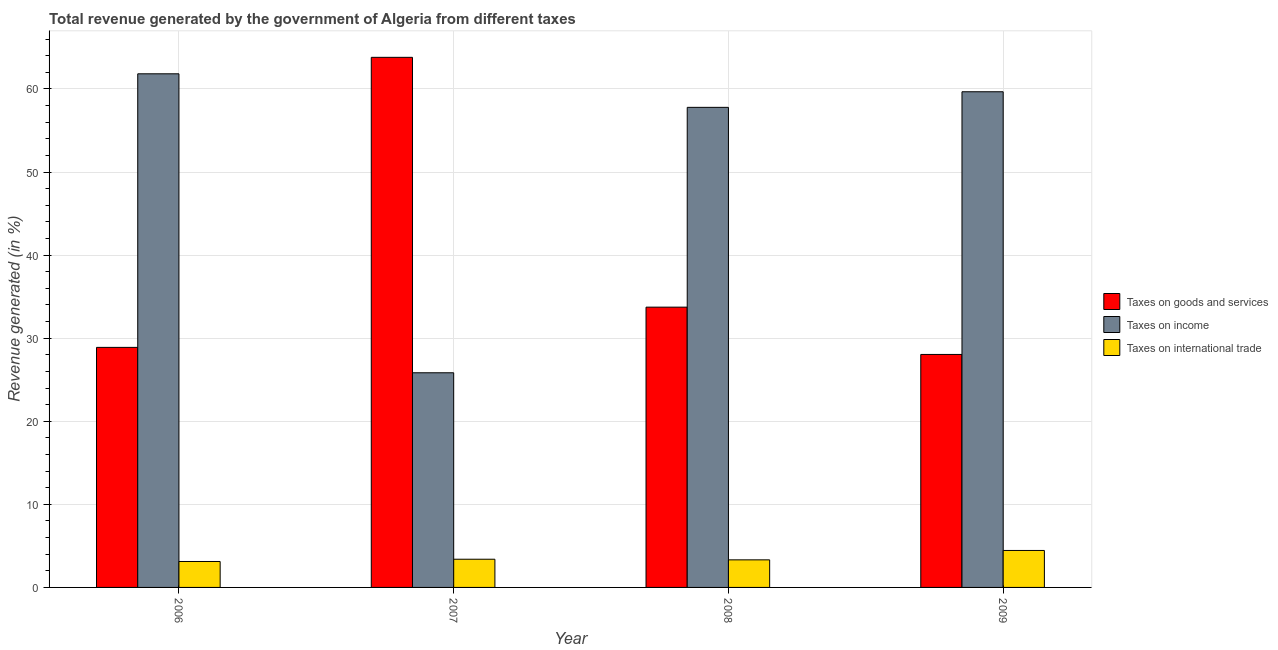How many different coloured bars are there?
Keep it short and to the point. 3. Are the number of bars per tick equal to the number of legend labels?
Your response must be concise. Yes. What is the label of the 1st group of bars from the left?
Provide a short and direct response. 2006. In how many cases, is the number of bars for a given year not equal to the number of legend labels?
Keep it short and to the point. 0. What is the percentage of revenue generated by taxes on goods and services in 2007?
Provide a succinct answer. 63.81. Across all years, what is the maximum percentage of revenue generated by taxes on goods and services?
Your answer should be very brief. 63.81. Across all years, what is the minimum percentage of revenue generated by tax on international trade?
Your response must be concise. 3.12. In which year was the percentage of revenue generated by taxes on income maximum?
Make the answer very short. 2006. What is the total percentage of revenue generated by taxes on income in the graph?
Make the answer very short. 205.11. What is the difference between the percentage of revenue generated by tax on international trade in 2008 and that in 2009?
Make the answer very short. -1.13. What is the difference between the percentage of revenue generated by taxes on goods and services in 2007 and the percentage of revenue generated by taxes on income in 2009?
Ensure brevity in your answer.  35.76. What is the average percentage of revenue generated by taxes on income per year?
Your answer should be compact. 51.28. In how many years, is the percentage of revenue generated by taxes on goods and services greater than 30 %?
Your answer should be compact. 2. What is the ratio of the percentage of revenue generated by taxes on goods and services in 2008 to that in 2009?
Ensure brevity in your answer.  1.2. Is the percentage of revenue generated by taxes on goods and services in 2008 less than that in 2009?
Offer a very short reply. No. What is the difference between the highest and the second highest percentage of revenue generated by tax on international trade?
Your answer should be compact. 1.06. What is the difference between the highest and the lowest percentage of revenue generated by tax on international trade?
Provide a short and direct response. 1.33. Is the sum of the percentage of revenue generated by taxes on income in 2006 and 2009 greater than the maximum percentage of revenue generated by taxes on goods and services across all years?
Ensure brevity in your answer.  Yes. What does the 1st bar from the left in 2009 represents?
Provide a short and direct response. Taxes on goods and services. What does the 2nd bar from the right in 2007 represents?
Ensure brevity in your answer.  Taxes on income. Is it the case that in every year, the sum of the percentage of revenue generated by taxes on goods and services and percentage of revenue generated by taxes on income is greater than the percentage of revenue generated by tax on international trade?
Offer a terse response. Yes. How many bars are there?
Give a very brief answer. 12. What is the difference between two consecutive major ticks on the Y-axis?
Provide a short and direct response. 10. Does the graph contain grids?
Ensure brevity in your answer.  Yes. How many legend labels are there?
Your answer should be compact. 3. How are the legend labels stacked?
Your answer should be very brief. Vertical. What is the title of the graph?
Keep it short and to the point. Total revenue generated by the government of Algeria from different taxes. Does "Resident buildings and public services" appear as one of the legend labels in the graph?
Make the answer very short. No. What is the label or title of the Y-axis?
Keep it short and to the point. Revenue generated (in %). What is the Revenue generated (in %) in Taxes on goods and services in 2006?
Your answer should be very brief. 28.89. What is the Revenue generated (in %) in Taxes on income in 2006?
Give a very brief answer. 61.82. What is the Revenue generated (in %) of Taxes on international trade in 2006?
Ensure brevity in your answer.  3.12. What is the Revenue generated (in %) of Taxes on goods and services in 2007?
Give a very brief answer. 63.81. What is the Revenue generated (in %) of Taxes on income in 2007?
Make the answer very short. 25.84. What is the Revenue generated (in %) of Taxes on international trade in 2007?
Give a very brief answer. 3.39. What is the Revenue generated (in %) in Taxes on goods and services in 2008?
Your response must be concise. 33.74. What is the Revenue generated (in %) of Taxes on income in 2008?
Your response must be concise. 57.79. What is the Revenue generated (in %) in Taxes on international trade in 2008?
Your answer should be compact. 3.32. What is the Revenue generated (in %) in Taxes on goods and services in 2009?
Offer a very short reply. 28.04. What is the Revenue generated (in %) of Taxes on income in 2009?
Offer a terse response. 59.66. What is the Revenue generated (in %) in Taxes on international trade in 2009?
Your answer should be very brief. 4.45. Across all years, what is the maximum Revenue generated (in %) in Taxes on goods and services?
Keep it short and to the point. 63.81. Across all years, what is the maximum Revenue generated (in %) of Taxes on income?
Provide a succinct answer. 61.82. Across all years, what is the maximum Revenue generated (in %) of Taxes on international trade?
Keep it short and to the point. 4.45. Across all years, what is the minimum Revenue generated (in %) of Taxes on goods and services?
Provide a short and direct response. 28.04. Across all years, what is the minimum Revenue generated (in %) of Taxes on income?
Offer a terse response. 25.84. Across all years, what is the minimum Revenue generated (in %) in Taxes on international trade?
Your response must be concise. 3.12. What is the total Revenue generated (in %) of Taxes on goods and services in the graph?
Provide a succinct answer. 154.48. What is the total Revenue generated (in %) in Taxes on income in the graph?
Your response must be concise. 205.11. What is the total Revenue generated (in %) of Taxes on international trade in the graph?
Keep it short and to the point. 14.28. What is the difference between the Revenue generated (in %) in Taxes on goods and services in 2006 and that in 2007?
Keep it short and to the point. -34.91. What is the difference between the Revenue generated (in %) of Taxes on income in 2006 and that in 2007?
Offer a terse response. 35.99. What is the difference between the Revenue generated (in %) of Taxes on international trade in 2006 and that in 2007?
Ensure brevity in your answer.  -0.27. What is the difference between the Revenue generated (in %) in Taxes on goods and services in 2006 and that in 2008?
Keep it short and to the point. -4.84. What is the difference between the Revenue generated (in %) in Taxes on income in 2006 and that in 2008?
Provide a succinct answer. 4.04. What is the difference between the Revenue generated (in %) of Taxes on international trade in 2006 and that in 2008?
Your answer should be very brief. -0.2. What is the difference between the Revenue generated (in %) of Taxes on goods and services in 2006 and that in 2009?
Give a very brief answer. 0.85. What is the difference between the Revenue generated (in %) of Taxes on income in 2006 and that in 2009?
Your answer should be compact. 2.16. What is the difference between the Revenue generated (in %) in Taxes on international trade in 2006 and that in 2009?
Offer a very short reply. -1.33. What is the difference between the Revenue generated (in %) of Taxes on goods and services in 2007 and that in 2008?
Your answer should be very brief. 30.07. What is the difference between the Revenue generated (in %) in Taxes on income in 2007 and that in 2008?
Offer a terse response. -31.95. What is the difference between the Revenue generated (in %) of Taxes on international trade in 2007 and that in 2008?
Make the answer very short. 0.07. What is the difference between the Revenue generated (in %) in Taxes on goods and services in 2007 and that in 2009?
Provide a succinct answer. 35.76. What is the difference between the Revenue generated (in %) of Taxes on income in 2007 and that in 2009?
Your answer should be very brief. -33.82. What is the difference between the Revenue generated (in %) of Taxes on international trade in 2007 and that in 2009?
Keep it short and to the point. -1.06. What is the difference between the Revenue generated (in %) of Taxes on goods and services in 2008 and that in 2009?
Your answer should be very brief. 5.69. What is the difference between the Revenue generated (in %) in Taxes on income in 2008 and that in 2009?
Your response must be concise. -1.88. What is the difference between the Revenue generated (in %) of Taxes on international trade in 2008 and that in 2009?
Give a very brief answer. -1.13. What is the difference between the Revenue generated (in %) of Taxes on goods and services in 2006 and the Revenue generated (in %) of Taxes on income in 2007?
Provide a short and direct response. 3.06. What is the difference between the Revenue generated (in %) in Taxes on goods and services in 2006 and the Revenue generated (in %) in Taxes on international trade in 2007?
Your response must be concise. 25.5. What is the difference between the Revenue generated (in %) in Taxes on income in 2006 and the Revenue generated (in %) in Taxes on international trade in 2007?
Your answer should be very brief. 58.43. What is the difference between the Revenue generated (in %) of Taxes on goods and services in 2006 and the Revenue generated (in %) of Taxes on income in 2008?
Keep it short and to the point. -28.89. What is the difference between the Revenue generated (in %) of Taxes on goods and services in 2006 and the Revenue generated (in %) of Taxes on international trade in 2008?
Provide a succinct answer. 25.57. What is the difference between the Revenue generated (in %) in Taxes on income in 2006 and the Revenue generated (in %) in Taxes on international trade in 2008?
Ensure brevity in your answer.  58.51. What is the difference between the Revenue generated (in %) in Taxes on goods and services in 2006 and the Revenue generated (in %) in Taxes on income in 2009?
Give a very brief answer. -30.77. What is the difference between the Revenue generated (in %) of Taxes on goods and services in 2006 and the Revenue generated (in %) of Taxes on international trade in 2009?
Provide a short and direct response. 24.44. What is the difference between the Revenue generated (in %) of Taxes on income in 2006 and the Revenue generated (in %) of Taxes on international trade in 2009?
Provide a succinct answer. 57.37. What is the difference between the Revenue generated (in %) of Taxes on goods and services in 2007 and the Revenue generated (in %) of Taxes on income in 2008?
Offer a very short reply. 6.02. What is the difference between the Revenue generated (in %) in Taxes on goods and services in 2007 and the Revenue generated (in %) in Taxes on international trade in 2008?
Give a very brief answer. 60.49. What is the difference between the Revenue generated (in %) in Taxes on income in 2007 and the Revenue generated (in %) in Taxes on international trade in 2008?
Keep it short and to the point. 22.52. What is the difference between the Revenue generated (in %) in Taxes on goods and services in 2007 and the Revenue generated (in %) in Taxes on income in 2009?
Provide a succinct answer. 4.14. What is the difference between the Revenue generated (in %) of Taxes on goods and services in 2007 and the Revenue generated (in %) of Taxes on international trade in 2009?
Offer a very short reply. 59.36. What is the difference between the Revenue generated (in %) of Taxes on income in 2007 and the Revenue generated (in %) of Taxes on international trade in 2009?
Your answer should be very brief. 21.39. What is the difference between the Revenue generated (in %) in Taxes on goods and services in 2008 and the Revenue generated (in %) in Taxes on income in 2009?
Keep it short and to the point. -25.93. What is the difference between the Revenue generated (in %) in Taxes on goods and services in 2008 and the Revenue generated (in %) in Taxes on international trade in 2009?
Offer a terse response. 29.29. What is the difference between the Revenue generated (in %) of Taxes on income in 2008 and the Revenue generated (in %) of Taxes on international trade in 2009?
Provide a short and direct response. 53.34. What is the average Revenue generated (in %) of Taxes on goods and services per year?
Provide a succinct answer. 38.62. What is the average Revenue generated (in %) in Taxes on income per year?
Keep it short and to the point. 51.28. What is the average Revenue generated (in %) in Taxes on international trade per year?
Give a very brief answer. 3.57. In the year 2006, what is the difference between the Revenue generated (in %) in Taxes on goods and services and Revenue generated (in %) in Taxes on income?
Keep it short and to the point. -32.93. In the year 2006, what is the difference between the Revenue generated (in %) in Taxes on goods and services and Revenue generated (in %) in Taxes on international trade?
Make the answer very short. 25.77. In the year 2006, what is the difference between the Revenue generated (in %) in Taxes on income and Revenue generated (in %) in Taxes on international trade?
Provide a short and direct response. 58.7. In the year 2007, what is the difference between the Revenue generated (in %) of Taxes on goods and services and Revenue generated (in %) of Taxes on income?
Your response must be concise. 37.97. In the year 2007, what is the difference between the Revenue generated (in %) of Taxes on goods and services and Revenue generated (in %) of Taxes on international trade?
Give a very brief answer. 60.41. In the year 2007, what is the difference between the Revenue generated (in %) in Taxes on income and Revenue generated (in %) in Taxes on international trade?
Provide a short and direct response. 22.44. In the year 2008, what is the difference between the Revenue generated (in %) of Taxes on goods and services and Revenue generated (in %) of Taxes on income?
Make the answer very short. -24.05. In the year 2008, what is the difference between the Revenue generated (in %) in Taxes on goods and services and Revenue generated (in %) in Taxes on international trade?
Give a very brief answer. 30.42. In the year 2008, what is the difference between the Revenue generated (in %) of Taxes on income and Revenue generated (in %) of Taxes on international trade?
Ensure brevity in your answer.  54.47. In the year 2009, what is the difference between the Revenue generated (in %) in Taxes on goods and services and Revenue generated (in %) in Taxes on income?
Make the answer very short. -31.62. In the year 2009, what is the difference between the Revenue generated (in %) in Taxes on goods and services and Revenue generated (in %) in Taxes on international trade?
Ensure brevity in your answer.  23.59. In the year 2009, what is the difference between the Revenue generated (in %) in Taxes on income and Revenue generated (in %) in Taxes on international trade?
Ensure brevity in your answer.  55.21. What is the ratio of the Revenue generated (in %) in Taxes on goods and services in 2006 to that in 2007?
Make the answer very short. 0.45. What is the ratio of the Revenue generated (in %) in Taxes on income in 2006 to that in 2007?
Provide a short and direct response. 2.39. What is the ratio of the Revenue generated (in %) of Taxes on international trade in 2006 to that in 2007?
Your response must be concise. 0.92. What is the ratio of the Revenue generated (in %) in Taxes on goods and services in 2006 to that in 2008?
Make the answer very short. 0.86. What is the ratio of the Revenue generated (in %) in Taxes on income in 2006 to that in 2008?
Provide a short and direct response. 1.07. What is the ratio of the Revenue generated (in %) of Taxes on international trade in 2006 to that in 2008?
Keep it short and to the point. 0.94. What is the ratio of the Revenue generated (in %) of Taxes on goods and services in 2006 to that in 2009?
Give a very brief answer. 1.03. What is the ratio of the Revenue generated (in %) in Taxes on income in 2006 to that in 2009?
Ensure brevity in your answer.  1.04. What is the ratio of the Revenue generated (in %) in Taxes on international trade in 2006 to that in 2009?
Keep it short and to the point. 0.7. What is the ratio of the Revenue generated (in %) in Taxes on goods and services in 2007 to that in 2008?
Offer a terse response. 1.89. What is the ratio of the Revenue generated (in %) of Taxes on income in 2007 to that in 2008?
Your response must be concise. 0.45. What is the ratio of the Revenue generated (in %) of Taxes on international trade in 2007 to that in 2008?
Provide a short and direct response. 1.02. What is the ratio of the Revenue generated (in %) in Taxes on goods and services in 2007 to that in 2009?
Offer a terse response. 2.28. What is the ratio of the Revenue generated (in %) in Taxes on income in 2007 to that in 2009?
Your response must be concise. 0.43. What is the ratio of the Revenue generated (in %) of Taxes on international trade in 2007 to that in 2009?
Offer a terse response. 0.76. What is the ratio of the Revenue generated (in %) of Taxes on goods and services in 2008 to that in 2009?
Your response must be concise. 1.2. What is the ratio of the Revenue generated (in %) in Taxes on income in 2008 to that in 2009?
Provide a succinct answer. 0.97. What is the ratio of the Revenue generated (in %) of Taxes on international trade in 2008 to that in 2009?
Keep it short and to the point. 0.75. What is the difference between the highest and the second highest Revenue generated (in %) in Taxes on goods and services?
Offer a very short reply. 30.07. What is the difference between the highest and the second highest Revenue generated (in %) in Taxes on income?
Offer a very short reply. 2.16. What is the difference between the highest and the second highest Revenue generated (in %) in Taxes on international trade?
Give a very brief answer. 1.06. What is the difference between the highest and the lowest Revenue generated (in %) of Taxes on goods and services?
Provide a succinct answer. 35.76. What is the difference between the highest and the lowest Revenue generated (in %) of Taxes on income?
Ensure brevity in your answer.  35.99. What is the difference between the highest and the lowest Revenue generated (in %) in Taxes on international trade?
Provide a succinct answer. 1.33. 